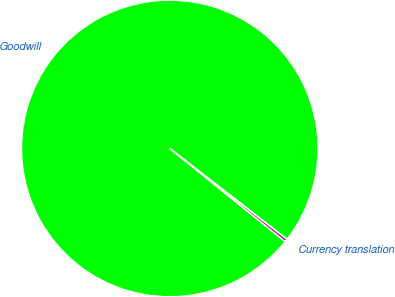<chart> <loc_0><loc_0><loc_500><loc_500><pie_chart><fcel>Goodwill<fcel>Currency translation<nl><fcel>99.69%<fcel>0.31%<nl></chart> 